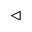Convert formula to latex. <formula><loc_0><loc_0><loc_500><loc_500>\triangleleft</formula> 